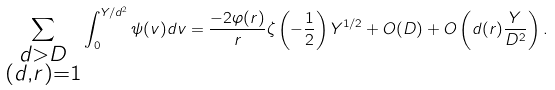<formula> <loc_0><loc_0><loc_500><loc_500>\sum _ { \substack { d > D \\ ( d , r ) = 1 } } \int _ { 0 } ^ { Y / d ^ { 2 } } \psi ( v ) d v = \frac { - 2 \varphi ( r ) } { r } \zeta \left ( - \frac { 1 } { 2 } \right ) Y ^ { 1 / 2 } + O ( D ) + O \left ( d ( r ) \frac { Y } { D ^ { 2 } } \right ) .</formula> 